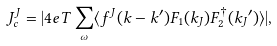Convert formula to latex. <formula><loc_0><loc_0><loc_500><loc_500>J _ { c } ^ { J } = | 4 e T \sum _ { \omega } \langle f ^ { J } ( { k } - { k } ^ { \prime } ) F _ { 1 } ( { k } _ { J } ) F _ { 2 } ^ { \dag } ( { k _ { J } } ^ { \prime } ) \rangle | ,</formula> 